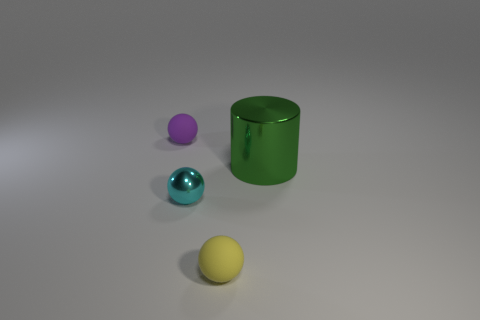Add 3 red cylinders. How many objects exist? 7 Subtract all cylinders. How many objects are left? 3 Subtract all cylinders. Subtract all small yellow objects. How many objects are left? 2 Add 2 metal spheres. How many metal spheres are left? 3 Add 1 big green rubber objects. How many big green rubber objects exist? 1 Subtract 0 blue cylinders. How many objects are left? 4 